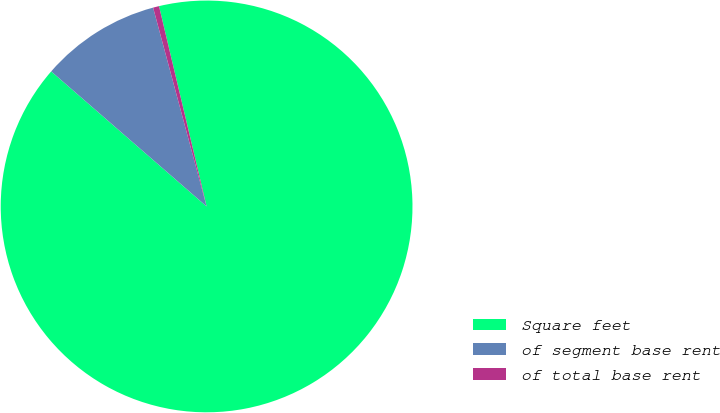<chart> <loc_0><loc_0><loc_500><loc_500><pie_chart><fcel>Square feet<fcel>of segment base rent<fcel>of total base rent<nl><fcel>90.1%<fcel>9.43%<fcel>0.47%<nl></chart> 